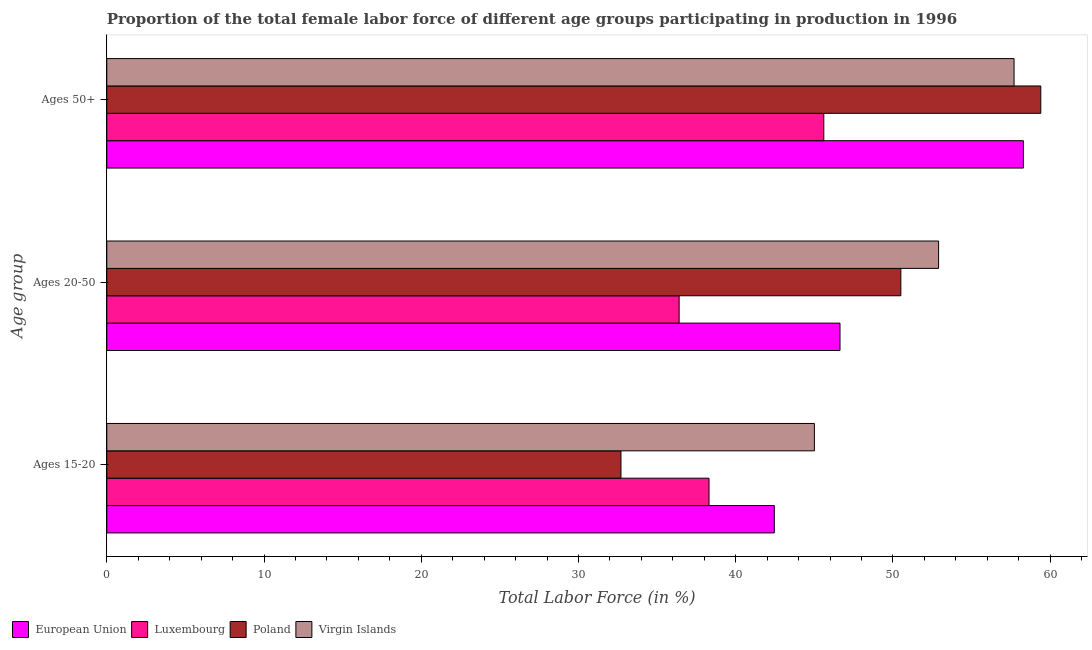Are the number of bars per tick equal to the number of legend labels?
Your response must be concise. Yes. How many bars are there on the 1st tick from the top?
Your answer should be compact. 4. What is the label of the 1st group of bars from the top?
Give a very brief answer. Ages 50+. What is the percentage of female labor force within the age group 15-20 in Poland?
Your response must be concise. 32.7. Across all countries, what is the maximum percentage of female labor force within the age group 20-50?
Your answer should be compact. 52.9. Across all countries, what is the minimum percentage of female labor force within the age group 15-20?
Provide a succinct answer. 32.7. In which country was the percentage of female labor force within the age group 20-50 maximum?
Ensure brevity in your answer.  Virgin Islands. In which country was the percentage of female labor force above age 50 minimum?
Make the answer very short. Luxembourg. What is the total percentage of female labor force within the age group 20-50 in the graph?
Ensure brevity in your answer.  186.43. What is the difference between the percentage of female labor force above age 50 in Virgin Islands and that in Poland?
Provide a short and direct response. -1.7. What is the difference between the percentage of female labor force within the age group 15-20 in Virgin Islands and the percentage of female labor force above age 50 in Luxembourg?
Your answer should be compact. -0.6. What is the average percentage of female labor force above age 50 per country?
Provide a short and direct response. 55.25. What is the difference between the percentage of female labor force above age 50 and percentage of female labor force within the age group 15-20 in Virgin Islands?
Offer a terse response. 12.7. In how many countries, is the percentage of female labor force above age 50 greater than 32 %?
Keep it short and to the point. 4. What is the ratio of the percentage of female labor force within the age group 20-50 in Virgin Islands to that in Luxembourg?
Provide a short and direct response. 1.45. Is the difference between the percentage of female labor force within the age group 20-50 in Poland and Luxembourg greater than the difference between the percentage of female labor force within the age group 15-20 in Poland and Luxembourg?
Keep it short and to the point. Yes. What is the difference between the highest and the second highest percentage of female labor force above age 50?
Provide a short and direct response. 1.11. What is the difference between the highest and the lowest percentage of female labor force above age 50?
Offer a terse response. 13.8. In how many countries, is the percentage of female labor force above age 50 greater than the average percentage of female labor force above age 50 taken over all countries?
Ensure brevity in your answer.  3. What does the 3rd bar from the top in Ages 20-50 represents?
Make the answer very short. Luxembourg. What does the 4th bar from the bottom in Ages 20-50 represents?
Offer a very short reply. Virgin Islands. How many bars are there?
Your response must be concise. 12. How many countries are there in the graph?
Make the answer very short. 4. What is the difference between two consecutive major ticks on the X-axis?
Provide a succinct answer. 10. Are the values on the major ticks of X-axis written in scientific E-notation?
Offer a very short reply. No. Does the graph contain any zero values?
Your answer should be compact. No. What is the title of the graph?
Your answer should be very brief. Proportion of the total female labor force of different age groups participating in production in 1996. Does "Lesotho" appear as one of the legend labels in the graph?
Offer a very short reply. No. What is the label or title of the Y-axis?
Offer a terse response. Age group. What is the Total Labor Force (in %) in European Union in Ages 15-20?
Your answer should be compact. 42.45. What is the Total Labor Force (in %) of Luxembourg in Ages 15-20?
Your answer should be very brief. 38.3. What is the Total Labor Force (in %) in Poland in Ages 15-20?
Keep it short and to the point. 32.7. What is the Total Labor Force (in %) of European Union in Ages 20-50?
Offer a very short reply. 46.63. What is the Total Labor Force (in %) of Luxembourg in Ages 20-50?
Keep it short and to the point. 36.4. What is the Total Labor Force (in %) in Poland in Ages 20-50?
Ensure brevity in your answer.  50.5. What is the Total Labor Force (in %) of Virgin Islands in Ages 20-50?
Keep it short and to the point. 52.9. What is the Total Labor Force (in %) of European Union in Ages 50+?
Offer a very short reply. 58.29. What is the Total Labor Force (in %) in Luxembourg in Ages 50+?
Your answer should be very brief. 45.6. What is the Total Labor Force (in %) of Poland in Ages 50+?
Provide a short and direct response. 59.4. What is the Total Labor Force (in %) in Virgin Islands in Ages 50+?
Your answer should be compact. 57.7. Across all Age group, what is the maximum Total Labor Force (in %) of European Union?
Give a very brief answer. 58.29. Across all Age group, what is the maximum Total Labor Force (in %) of Luxembourg?
Ensure brevity in your answer.  45.6. Across all Age group, what is the maximum Total Labor Force (in %) in Poland?
Give a very brief answer. 59.4. Across all Age group, what is the maximum Total Labor Force (in %) in Virgin Islands?
Offer a very short reply. 57.7. Across all Age group, what is the minimum Total Labor Force (in %) in European Union?
Provide a succinct answer. 42.45. Across all Age group, what is the minimum Total Labor Force (in %) in Luxembourg?
Keep it short and to the point. 36.4. Across all Age group, what is the minimum Total Labor Force (in %) of Poland?
Your response must be concise. 32.7. Across all Age group, what is the minimum Total Labor Force (in %) in Virgin Islands?
Ensure brevity in your answer.  45. What is the total Total Labor Force (in %) in European Union in the graph?
Your answer should be compact. 147.38. What is the total Total Labor Force (in %) in Luxembourg in the graph?
Your response must be concise. 120.3. What is the total Total Labor Force (in %) of Poland in the graph?
Offer a terse response. 142.6. What is the total Total Labor Force (in %) of Virgin Islands in the graph?
Provide a short and direct response. 155.6. What is the difference between the Total Labor Force (in %) in European Union in Ages 15-20 and that in Ages 20-50?
Make the answer very short. -4.18. What is the difference between the Total Labor Force (in %) in Luxembourg in Ages 15-20 and that in Ages 20-50?
Offer a very short reply. 1.9. What is the difference between the Total Labor Force (in %) in Poland in Ages 15-20 and that in Ages 20-50?
Your answer should be compact. -17.8. What is the difference between the Total Labor Force (in %) in Virgin Islands in Ages 15-20 and that in Ages 20-50?
Keep it short and to the point. -7.9. What is the difference between the Total Labor Force (in %) of European Union in Ages 15-20 and that in Ages 50+?
Ensure brevity in your answer.  -15.84. What is the difference between the Total Labor Force (in %) in Poland in Ages 15-20 and that in Ages 50+?
Make the answer very short. -26.7. What is the difference between the Total Labor Force (in %) of European Union in Ages 20-50 and that in Ages 50+?
Your answer should be very brief. -11.66. What is the difference between the Total Labor Force (in %) in Luxembourg in Ages 20-50 and that in Ages 50+?
Give a very brief answer. -9.2. What is the difference between the Total Labor Force (in %) of Virgin Islands in Ages 20-50 and that in Ages 50+?
Your answer should be very brief. -4.8. What is the difference between the Total Labor Force (in %) of European Union in Ages 15-20 and the Total Labor Force (in %) of Luxembourg in Ages 20-50?
Give a very brief answer. 6.05. What is the difference between the Total Labor Force (in %) in European Union in Ages 15-20 and the Total Labor Force (in %) in Poland in Ages 20-50?
Make the answer very short. -8.05. What is the difference between the Total Labor Force (in %) in European Union in Ages 15-20 and the Total Labor Force (in %) in Virgin Islands in Ages 20-50?
Offer a terse response. -10.45. What is the difference between the Total Labor Force (in %) in Luxembourg in Ages 15-20 and the Total Labor Force (in %) in Poland in Ages 20-50?
Give a very brief answer. -12.2. What is the difference between the Total Labor Force (in %) in Luxembourg in Ages 15-20 and the Total Labor Force (in %) in Virgin Islands in Ages 20-50?
Your answer should be compact. -14.6. What is the difference between the Total Labor Force (in %) in Poland in Ages 15-20 and the Total Labor Force (in %) in Virgin Islands in Ages 20-50?
Your response must be concise. -20.2. What is the difference between the Total Labor Force (in %) of European Union in Ages 15-20 and the Total Labor Force (in %) of Luxembourg in Ages 50+?
Your answer should be compact. -3.15. What is the difference between the Total Labor Force (in %) in European Union in Ages 15-20 and the Total Labor Force (in %) in Poland in Ages 50+?
Provide a succinct answer. -16.95. What is the difference between the Total Labor Force (in %) of European Union in Ages 15-20 and the Total Labor Force (in %) of Virgin Islands in Ages 50+?
Provide a succinct answer. -15.25. What is the difference between the Total Labor Force (in %) in Luxembourg in Ages 15-20 and the Total Labor Force (in %) in Poland in Ages 50+?
Keep it short and to the point. -21.1. What is the difference between the Total Labor Force (in %) in Luxembourg in Ages 15-20 and the Total Labor Force (in %) in Virgin Islands in Ages 50+?
Provide a succinct answer. -19.4. What is the difference between the Total Labor Force (in %) of Poland in Ages 15-20 and the Total Labor Force (in %) of Virgin Islands in Ages 50+?
Keep it short and to the point. -25. What is the difference between the Total Labor Force (in %) of European Union in Ages 20-50 and the Total Labor Force (in %) of Luxembourg in Ages 50+?
Offer a very short reply. 1.03. What is the difference between the Total Labor Force (in %) of European Union in Ages 20-50 and the Total Labor Force (in %) of Poland in Ages 50+?
Your response must be concise. -12.77. What is the difference between the Total Labor Force (in %) of European Union in Ages 20-50 and the Total Labor Force (in %) of Virgin Islands in Ages 50+?
Make the answer very short. -11.07. What is the difference between the Total Labor Force (in %) in Luxembourg in Ages 20-50 and the Total Labor Force (in %) in Poland in Ages 50+?
Make the answer very short. -23. What is the difference between the Total Labor Force (in %) of Luxembourg in Ages 20-50 and the Total Labor Force (in %) of Virgin Islands in Ages 50+?
Offer a very short reply. -21.3. What is the difference between the Total Labor Force (in %) of Poland in Ages 20-50 and the Total Labor Force (in %) of Virgin Islands in Ages 50+?
Ensure brevity in your answer.  -7.2. What is the average Total Labor Force (in %) of European Union per Age group?
Keep it short and to the point. 49.13. What is the average Total Labor Force (in %) of Luxembourg per Age group?
Offer a terse response. 40.1. What is the average Total Labor Force (in %) of Poland per Age group?
Offer a very short reply. 47.53. What is the average Total Labor Force (in %) in Virgin Islands per Age group?
Offer a very short reply. 51.87. What is the difference between the Total Labor Force (in %) in European Union and Total Labor Force (in %) in Luxembourg in Ages 15-20?
Your answer should be very brief. 4.15. What is the difference between the Total Labor Force (in %) in European Union and Total Labor Force (in %) in Poland in Ages 15-20?
Provide a short and direct response. 9.75. What is the difference between the Total Labor Force (in %) of European Union and Total Labor Force (in %) of Virgin Islands in Ages 15-20?
Ensure brevity in your answer.  -2.55. What is the difference between the Total Labor Force (in %) of Luxembourg and Total Labor Force (in %) of Virgin Islands in Ages 15-20?
Your answer should be very brief. -6.7. What is the difference between the Total Labor Force (in %) in European Union and Total Labor Force (in %) in Luxembourg in Ages 20-50?
Your answer should be compact. 10.23. What is the difference between the Total Labor Force (in %) of European Union and Total Labor Force (in %) of Poland in Ages 20-50?
Provide a short and direct response. -3.87. What is the difference between the Total Labor Force (in %) of European Union and Total Labor Force (in %) of Virgin Islands in Ages 20-50?
Your response must be concise. -6.27. What is the difference between the Total Labor Force (in %) in Luxembourg and Total Labor Force (in %) in Poland in Ages 20-50?
Provide a short and direct response. -14.1. What is the difference between the Total Labor Force (in %) of Luxembourg and Total Labor Force (in %) of Virgin Islands in Ages 20-50?
Ensure brevity in your answer.  -16.5. What is the difference between the Total Labor Force (in %) of Poland and Total Labor Force (in %) of Virgin Islands in Ages 20-50?
Offer a terse response. -2.4. What is the difference between the Total Labor Force (in %) in European Union and Total Labor Force (in %) in Luxembourg in Ages 50+?
Ensure brevity in your answer.  12.69. What is the difference between the Total Labor Force (in %) of European Union and Total Labor Force (in %) of Poland in Ages 50+?
Give a very brief answer. -1.11. What is the difference between the Total Labor Force (in %) of European Union and Total Labor Force (in %) of Virgin Islands in Ages 50+?
Your answer should be compact. 0.59. What is the difference between the Total Labor Force (in %) in Luxembourg and Total Labor Force (in %) in Poland in Ages 50+?
Your answer should be very brief. -13.8. What is the difference between the Total Labor Force (in %) in Poland and Total Labor Force (in %) in Virgin Islands in Ages 50+?
Offer a very short reply. 1.7. What is the ratio of the Total Labor Force (in %) of European Union in Ages 15-20 to that in Ages 20-50?
Keep it short and to the point. 0.91. What is the ratio of the Total Labor Force (in %) in Luxembourg in Ages 15-20 to that in Ages 20-50?
Your answer should be very brief. 1.05. What is the ratio of the Total Labor Force (in %) of Poland in Ages 15-20 to that in Ages 20-50?
Offer a very short reply. 0.65. What is the ratio of the Total Labor Force (in %) in Virgin Islands in Ages 15-20 to that in Ages 20-50?
Your answer should be compact. 0.85. What is the ratio of the Total Labor Force (in %) in European Union in Ages 15-20 to that in Ages 50+?
Provide a short and direct response. 0.73. What is the ratio of the Total Labor Force (in %) in Luxembourg in Ages 15-20 to that in Ages 50+?
Give a very brief answer. 0.84. What is the ratio of the Total Labor Force (in %) in Poland in Ages 15-20 to that in Ages 50+?
Ensure brevity in your answer.  0.55. What is the ratio of the Total Labor Force (in %) in Virgin Islands in Ages 15-20 to that in Ages 50+?
Offer a very short reply. 0.78. What is the ratio of the Total Labor Force (in %) of European Union in Ages 20-50 to that in Ages 50+?
Provide a short and direct response. 0.8. What is the ratio of the Total Labor Force (in %) in Luxembourg in Ages 20-50 to that in Ages 50+?
Make the answer very short. 0.8. What is the ratio of the Total Labor Force (in %) of Poland in Ages 20-50 to that in Ages 50+?
Provide a short and direct response. 0.85. What is the ratio of the Total Labor Force (in %) of Virgin Islands in Ages 20-50 to that in Ages 50+?
Your response must be concise. 0.92. What is the difference between the highest and the second highest Total Labor Force (in %) in European Union?
Offer a terse response. 11.66. What is the difference between the highest and the second highest Total Labor Force (in %) of Luxembourg?
Your response must be concise. 7.3. What is the difference between the highest and the second highest Total Labor Force (in %) of Virgin Islands?
Provide a succinct answer. 4.8. What is the difference between the highest and the lowest Total Labor Force (in %) of European Union?
Offer a terse response. 15.84. What is the difference between the highest and the lowest Total Labor Force (in %) in Luxembourg?
Offer a very short reply. 9.2. What is the difference between the highest and the lowest Total Labor Force (in %) of Poland?
Your answer should be compact. 26.7. 